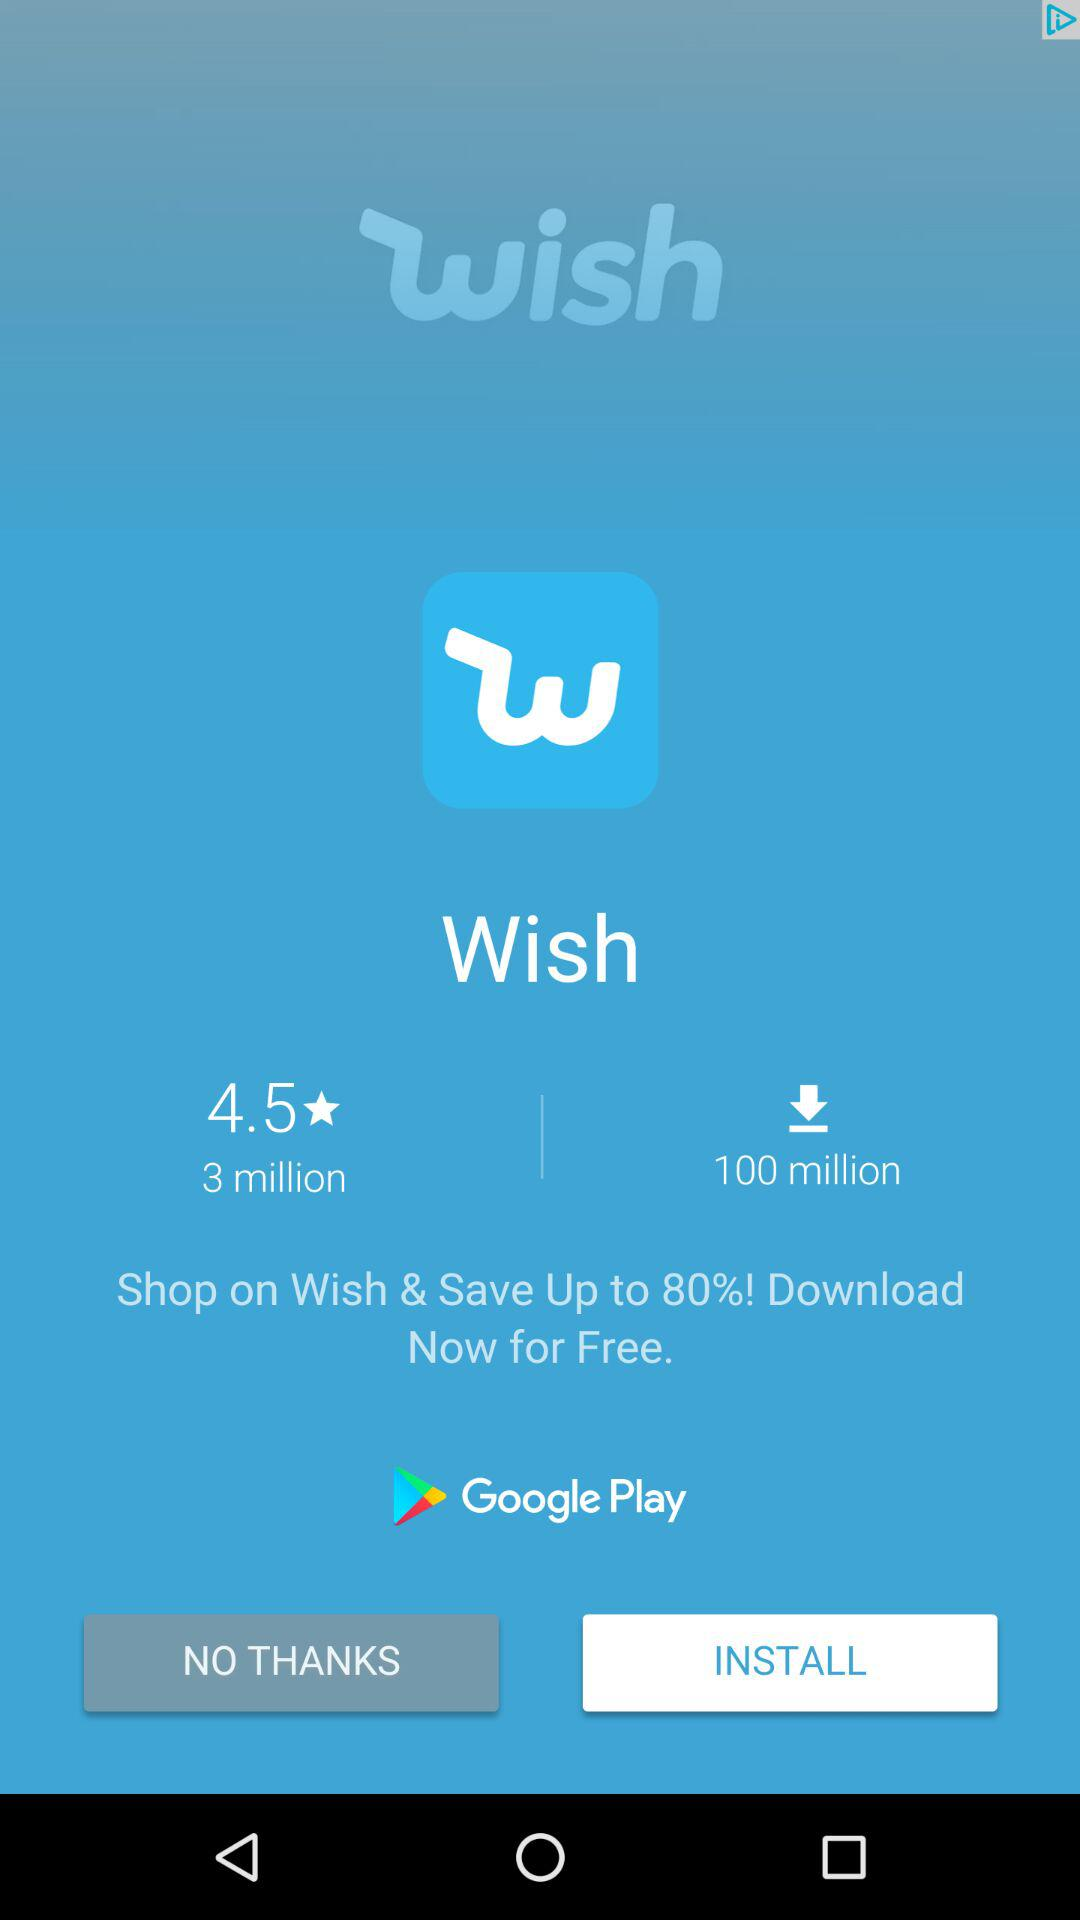How many more downloads does Wish have than reviews?
Answer the question using a single word or phrase. 97 million 